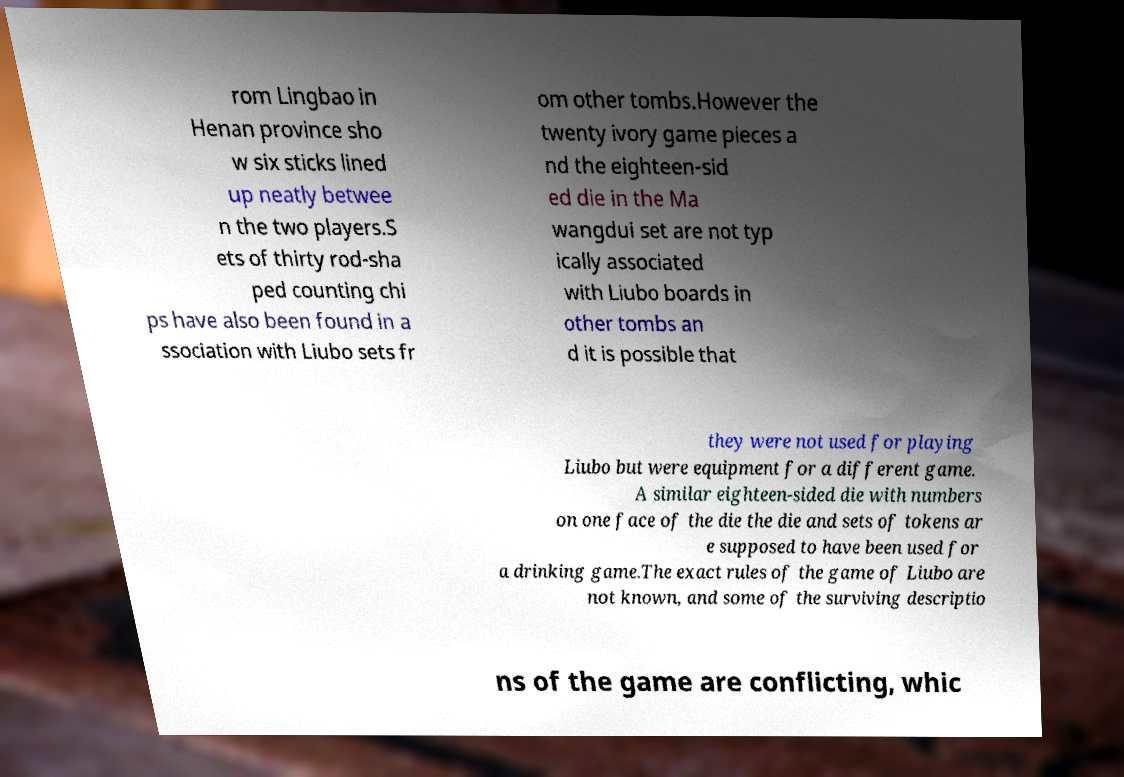I need the written content from this picture converted into text. Can you do that? rom Lingbao in Henan province sho w six sticks lined up neatly betwee n the two players.S ets of thirty rod-sha ped counting chi ps have also been found in a ssociation with Liubo sets fr om other tombs.However the twenty ivory game pieces a nd the eighteen-sid ed die in the Ma wangdui set are not typ ically associated with Liubo boards in other tombs an d it is possible that they were not used for playing Liubo but were equipment for a different game. A similar eighteen-sided die with numbers on one face of the die the die and sets of tokens ar e supposed to have been used for a drinking game.The exact rules of the game of Liubo are not known, and some of the surviving descriptio ns of the game are conflicting, whic 